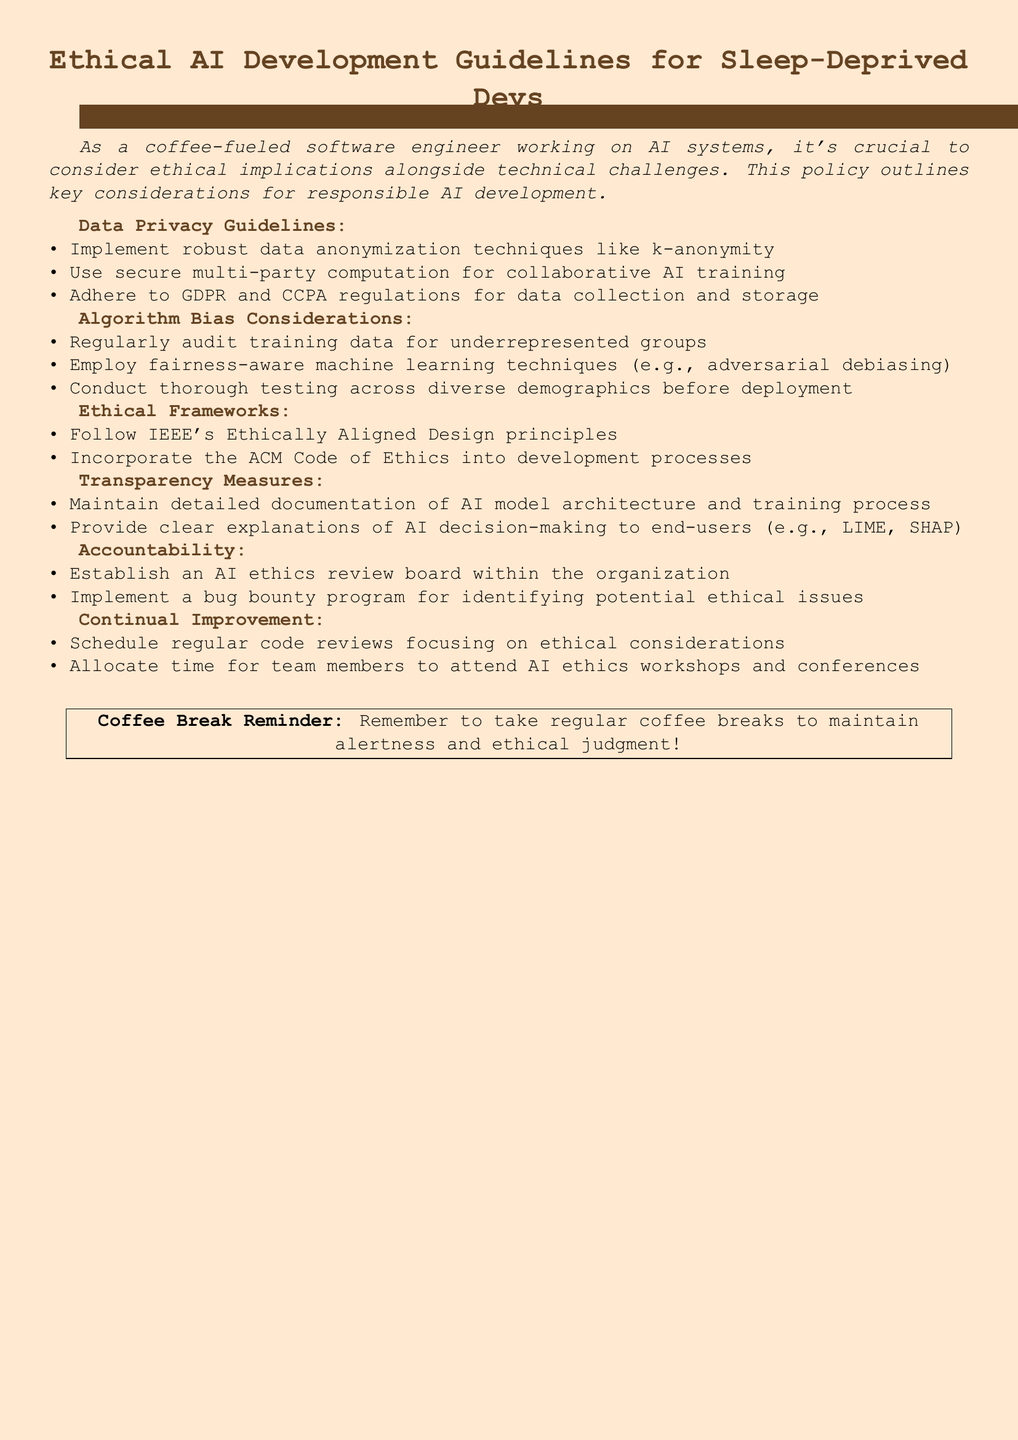What are the guidelines for data privacy? The document lists specific guidelines including robust data anonymization techniques, secure multi-party computation, and adherence to GDPR and CCPA regulations.
Answer: Robust data anonymization techniques like k-anonymity, secure multi-party computation for collaborative AI training, GDPR and CCPA regulations What is one method for addressing algorithm bias? The document mentions various methods to address algorithm bias, including auditing training data and employing fairness-aware techniques.
Answer: Regularly audit training data for underrepresented groups Which ethical framework principles are mentioned? The document references IEEE's Ethically Aligned Design principles and ACM Code of Ethics as essential frameworks.
Answer: IEEE's Ethically Aligned Design principles, ACM Code of Ethics How often should code reviews focusing on ethical considerations be scheduled? The document indicates that scheduling regular code reviews is part of the continual improvement recommendation.
Answer: Regularly What is a recommended transparency measure in the document? The document suggests maintaining detailed documentation of AI model architecture and providing clear explanations of AI decision-making.
Answer: Maintain detailed documentation of AI model architecture and training process What can organizations establish to ensure accountability in AI development? The document proposes establishing an AI ethics review board and implementing a bug bounty program for ethical issues.
Answer: Establish an AI ethics review board What should team members allocate time for? The document states that team members should allocate time to attend AI ethics workshops and conferences as part of continual improvement.
Answer: Attend AI ethics workshops and conferences What is emphasized for maintaining ethical judgment? The document includes a reminder about taking regular coffee breaks to maintain alertness and ethical judgment.
Answer: Regular coffee breaks 